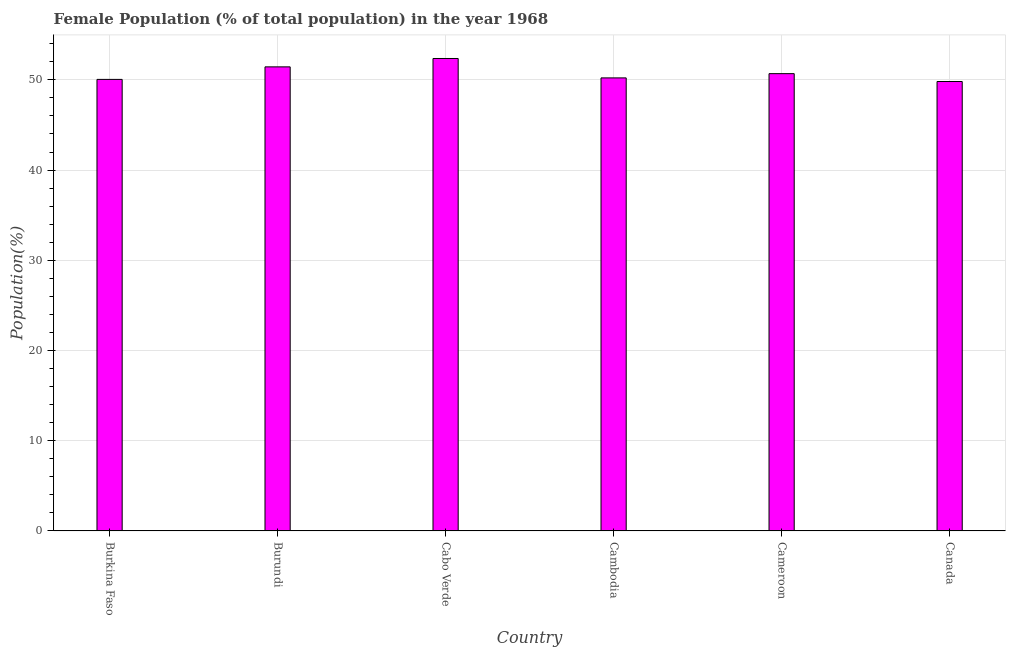What is the title of the graph?
Give a very brief answer. Female Population (% of total population) in the year 1968. What is the label or title of the X-axis?
Make the answer very short. Country. What is the label or title of the Y-axis?
Your answer should be very brief. Population(%). What is the female population in Cameroon?
Provide a short and direct response. 50.69. Across all countries, what is the maximum female population?
Provide a short and direct response. 52.37. Across all countries, what is the minimum female population?
Your response must be concise. 49.82. In which country was the female population maximum?
Give a very brief answer. Cabo Verde. What is the sum of the female population?
Your answer should be compact. 304.57. What is the difference between the female population in Cambodia and Cameroon?
Provide a succinct answer. -0.47. What is the average female population per country?
Your answer should be compact. 50.76. What is the median female population?
Provide a succinct answer. 50.45. Is the difference between the female population in Burkina Faso and Cameroon greater than the difference between any two countries?
Keep it short and to the point. No. What is the difference between the highest and the second highest female population?
Provide a succinct answer. 0.93. Is the sum of the female population in Cameroon and Canada greater than the maximum female population across all countries?
Offer a very short reply. Yes. What is the difference between the highest and the lowest female population?
Provide a short and direct response. 2.55. In how many countries, is the female population greater than the average female population taken over all countries?
Your answer should be compact. 2. How many countries are there in the graph?
Your response must be concise. 6. What is the difference between two consecutive major ticks on the Y-axis?
Give a very brief answer. 10. What is the Population(%) in Burkina Faso?
Give a very brief answer. 50.05. What is the Population(%) in Burundi?
Give a very brief answer. 51.44. What is the Population(%) of Cabo Verde?
Make the answer very short. 52.37. What is the Population(%) in Cambodia?
Provide a succinct answer. 50.22. What is the Population(%) in Cameroon?
Your answer should be compact. 50.69. What is the Population(%) of Canada?
Provide a short and direct response. 49.82. What is the difference between the Population(%) in Burkina Faso and Burundi?
Make the answer very short. -1.39. What is the difference between the Population(%) in Burkina Faso and Cabo Verde?
Keep it short and to the point. -2.32. What is the difference between the Population(%) in Burkina Faso and Cambodia?
Give a very brief answer. -0.17. What is the difference between the Population(%) in Burkina Faso and Cameroon?
Offer a terse response. -0.64. What is the difference between the Population(%) in Burkina Faso and Canada?
Provide a short and direct response. 0.23. What is the difference between the Population(%) in Burundi and Cabo Verde?
Offer a very short reply. -0.93. What is the difference between the Population(%) in Burundi and Cambodia?
Your response must be concise. 1.22. What is the difference between the Population(%) in Burundi and Cameroon?
Provide a succinct answer. 0.75. What is the difference between the Population(%) in Burundi and Canada?
Ensure brevity in your answer.  1.62. What is the difference between the Population(%) in Cabo Verde and Cambodia?
Your answer should be very brief. 2.15. What is the difference between the Population(%) in Cabo Verde and Cameroon?
Your response must be concise. 1.68. What is the difference between the Population(%) in Cabo Verde and Canada?
Your answer should be very brief. 2.55. What is the difference between the Population(%) in Cambodia and Cameroon?
Keep it short and to the point. -0.47. What is the difference between the Population(%) in Cambodia and Canada?
Give a very brief answer. 0.4. What is the difference between the Population(%) in Cameroon and Canada?
Offer a terse response. 0.87. What is the ratio of the Population(%) in Burkina Faso to that in Burundi?
Give a very brief answer. 0.97. What is the ratio of the Population(%) in Burkina Faso to that in Cabo Verde?
Ensure brevity in your answer.  0.96. What is the ratio of the Population(%) in Burkina Faso to that in Cambodia?
Give a very brief answer. 1. What is the ratio of the Population(%) in Burkina Faso to that in Cameroon?
Keep it short and to the point. 0.99. What is the ratio of the Population(%) in Burkina Faso to that in Canada?
Your response must be concise. 1. What is the ratio of the Population(%) in Burundi to that in Canada?
Your response must be concise. 1.03. What is the ratio of the Population(%) in Cabo Verde to that in Cambodia?
Your answer should be compact. 1.04. What is the ratio of the Population(%) in Cabo Verde to that in Cameroon?
Offer a terse response. 1.03. What is the ratio of the Population(%) in Cabo Verde to that in Canada?
Offer a very short reply. 1.05. What is the ratio of the Population(%) in Cambodia to that in Canada?
Offer a very short reply. 1.01. 